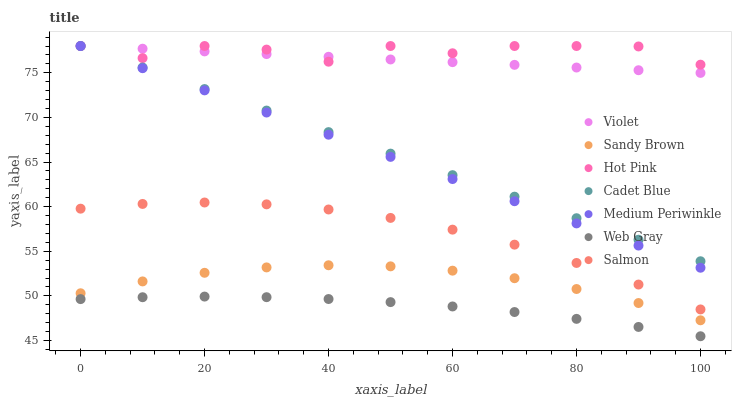Does Web Gray have the minimum area under the curve?
Answer yes or no. Yes. Does Hot Pink have the maximum area under the curve?
Answer yes or no. Yes. Does Salmon have the minimum area under the curve?
Answer yes or no. No. Does Salmon have the maximum area under the curve?
Answer yes or no. No. Is Violet the smoothest?
Answer yes or no. Yes. Is Hot Pink the roughest?
Answer yes or no. Yes. Is Salmon the smoothest?
Answer yes or no. No. Is Salmon the roughest?
Answer yes or no. No. Does Web Gray have the lowest value?
Answer yes or no. Yes. Does Salmon have the lowest value?
Answer yes or no. No. Does Violet have the highest value?
Answer yes or no. Yes. Does Salmon have the highest value?
Answer yes or no. No. Is Sandy Brown less than Salmon?
Answer yes or no. Yes. Is Hot Pink greater than Sandy Brown?
Answer yes or no. Yes. Does Cadet Blue intersect Hot Pink?
Answer yes or no. Yes. Is Cadet Blue less than Hot Pink?
Answer yes or no. No. Is Cadet Blue greater than Hot Pink?
Answer yes or no. No. Does Sandy Brown intersect Salmon?
Answer yes or no. No. 